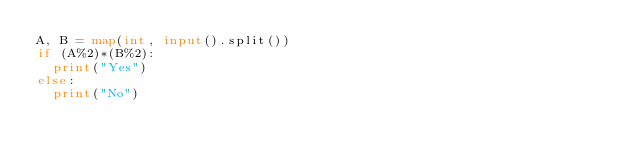Convert code to text. <code><loc_0><loc_0><loc_500><loc_500><_Python_>A, B = map(int, input().split())
if (A%2)*(B%2):
  print("Yes")
else:
  print("No")</code> 